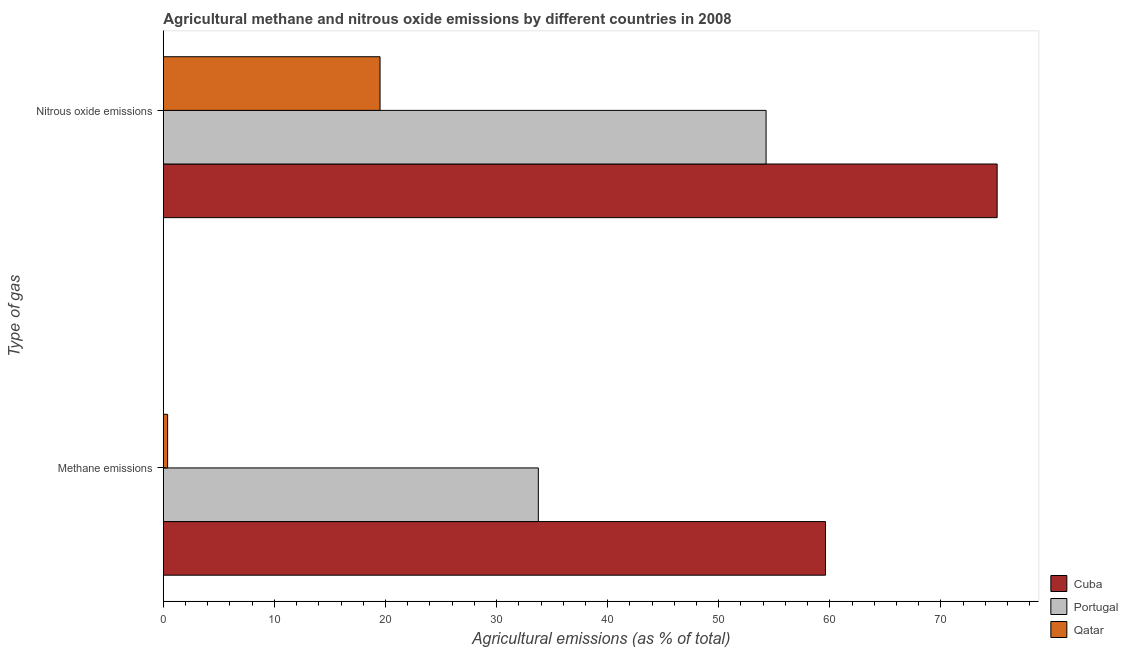How many different coloured bars are there?
Give a very brief answer. 3. How many groups of bars are there?
Offer a very short reply. 2. Are the number of bars on each tick of the Y-axis equal?
Offer a terse response. Yes. How many bars are there on the 2nd tick from the top?
Offer a very short reply. 3. What is the label of the 1st group of bars from the top?
Ensure brevity in your answer.  Nitrous oxide emissions. What is the amount of nitrous oxide emissions in Portugal?
Provide a short and direct response. 54.26. Across all countries, what is the maximum amount of nitrous oxide emissions?
Provide a short and direct response. 75.06. Across all countries, what is the minimum amount of methane emissions?
Keep it short and to the point. 0.39. In which country was the amount of methane emissions maximum?
Provide a succinct answer. Cuba. In which country was the amount of methane emissions minimum?
Your response must be concise. Qatar. What is the total amount of nitrous oxide emissions in the graph?
Provide a succinct answer. 148.83. What is the difference between the amount of methane emissions in Cuba and that in Portugal?
Make the answer very short. 25.85. What is the difference between the amount of methane emissions in Portugal and the amount of nitrous oxide emissions in Qatar?
Ensure brevity in your answer.  14.25. What is the average amount of nitrous oxide emissions per country?
Ensure brevity in your answer.  49.61. What is the difference between the amount of methane emissions and amount of nitrous oxide emissions in Portugal?
Give a very brief answer. -20.5. What is the ratio of the amount of nitrous oxide emissions in Portugal to that in Qatar?
Provide a succinct answer. 2.78. Is the amount of nitrous oxide emissions in Qatar less than that in Portugal?
Ensure brevity in your answer.  Yes. What does the 1st bar from the top in Methane emissions represents?
Keep it short and to the point. Qatar. What does the 3rd bar from the bottom in Methane emissions represents?
Offer a very short reply. Qatar. How many countries are there in the graph?
Your answer should be very brief. 3. Does the graph contain grids?
Make the answer very short. No. Where does the legend appear in the graph?
Keep it short and to the point. Bottom right. How are the legend labels stacked?
Ensure brevity in your answer.  Vertical. What is the title of the graph?
Offer a terse response. Agricultural methane and nitrous oxide emissions by different countries in 2008. Does "Canada" appear as one of the legend labels in the graph?
Make the answer very short. No. What is the label or title of the X-axis?
Keep it short and to the point. Agricultural emissions (as % of total). What is the label or title of the Y-axis?
Give a very brief answer. Type of gas. What is the Agricultural emissions (as % of total) of Cuba in Methane emissions?
Provide a succinct answer. 59.61. What is the Agricultural emissions (as % of total) in Portugal in Methane emissions?
Ensure brevity in your answer.  33.76. What is the Agricultural emissions (as % of total) in Qatar in Methane emissions?
Offer a very short reply. 0.39. What is the Agricultural emissions (as % of total) in Cuba in Nitrous oxide emissions?
Ensure brevity in your answer.  75.06. What is the Agricultural emissions (as % of total) of Portugal in Nitrous oxide emissions?
Keep it short and to the point. 54.26. What is the Agricultural emissions (as % of total) of Qatar in Nitrous oxide emissions?
Keep it short and to the point. 19.51. Across all Type of gas, what is the maximum Agricultural emissions (as % of total) in Cuba?
Make the answer very short. 75.06. Across all Type of gas, what is the maximum Agricultural emissions (as % of total) in Portugal?
Your answer should be compact. 54.26. Across all Type of gas, what is the maximum Agricultural emissions (as % of total) of Qatar?
Offer a very short reply. 19.51. Across all Type of gas, what is the minimum Agricultural emissions (as % of total) in Cuba?
Provide a succinct answer. 59.61. Across all Type of gas, what is the minimum Agricultural emissions (as % of total) of Portugal?
Make the answer very short. 33.76. Across all Type of gas, what is the minimum Agricultural emissions (as % of total) in Qatar?
Offer a very short reply. 0.39. What is the total Agricultural emissions (as % of total) of Cuba in the graph?
Keep it short and to the point. 134.67. What is the total Agricultural emissions (as % of total) in Portugal in the graph?
Give a very brief answer. 88.02. What is the total Agricultural emissions (as % of total) of Qatar in the graph?
Offer a very short reply. 19.9. What is the difference between the Agricultural emissions (as % of total) in Cuba in Methane emissions and that in Nitrous oxide emissions?
Keep it short and to the point. -15.45. What is the difference between the Agricultural emissions (as % of total) in Portugal in Methane emissions and that in Nitrous oxide emissions?
Keep it short and to the point. -20.5. What is the difference between the Agricultural emissions (as % of total) in Qatar in Methane emissions and that in Nitrous oxide emissions?
Offer a terse response. -19.12. What is the difference between the Agricultural emissions (as % of total) in Cuba in Methane emissions and the Agricultural emissions (as % of total) in Portugal in Nitrous oxide emissions?
Make the answer very short. 5.35. What is the difference between the Agricultural emissions (as % of total) in Cuba in Methane emissions and the Agricultural emissions (as % of total) in Qatar in Nitrous oxide emissions?
Provide a succinct answer. 40.1. What is the difference between the Agricultural emissions (as % of total) of Portugal in Methane emissions and the Agricultural emissions (as % of total) of Qatar in Nitrous oxide emissions?
Offer a very short reply. 14.25. What is the average Agricultural emissions (as % of total) of Cuba per Type of gas?
Offer a terse response. 67.33. What is the average Agricultural emissions (as % of total) in Portugal per Type of gas?
Your response must be concise. 44.01. What is the average Agricultural emissions (as % of total) in Qatar per Type of gas?
Provide a succinct answer. 9.95. What is the difference between the Agricultural emissions (as % of total) in Cuba and Agricultural emissions (as % of total) in Portugal in Methane emissions?
Keep it short and to the point. 25.85. What is the difference between the Agricultural emissions (as % of total) of Cuba and Agricultural emissions (as % of total) of Qatar in Methane emissions?
Provide a succinct answer. 59.22. What is the difference between the Agricultural emissions (as % of total) in Portugal and Agricultural emissions (as % of total) in Qatar in Methane emissions?
Your answer should be compact. 33.37. What is the difference between the Agricultural emissions (as % of total) of Cuba and Agricultural emissions (as % of total) of Portugal in Nitrous oxide emissions?
Give a very brief answer. 20.8. What is the difference between the Agricultural emissions (as % of total) in Cuba and Agricultural emissions (as % of total) in Qatar in Nitrous oxide emissions?
Keep it short and to the point. 55.55. What is the difference between the Agricultural emissions (as % of total) in Portugal and Agricultural emissions (as % of total) in Qatar in Nitrous oxide emissions?
Give a very brief answer. 34.75. What is the ratio of the Agricultural emissions (as % of total) of Cuba in Methane emissions to that in Nitrous oxide emissions?
Keep it short and to the point. 0.79. What is the ratio of the Agricultural emissions (as % of total) of Portugal in Methane emissions to that in Nitrous oxide emissions?
Your answer should be very brief. 0.62. What is the ratio of the Agricultural emissions (as % of total) of Qatar in Methane emissions to that in Nitrous oxide emissions?
Your response must be concise. 0.02. What is the difference between the highest and the second highest Agricultural emissions (as % of total) in Cuba?
Ensure brevity in your answer.  15.45. What is the difference between the highest and the second highest Agricultural emissions (as % of total) in Portugal?
Provide a succinct answer. 20.5. What is the difference between the highest and the second highest Agricultural emissions (as % of total) of Qatar?
Offer a terse response. 19.12. What is the difference between the highest and the lowest Agricultural emissions (as % of total) in Cuba?
Provide a succinct answer. 15.45. What is the difference between the highest and the lowest Agricultural emissions (as % of total) of Portugal?
Ensure brevity in your answer.  20.5. What is the difference between the highest and the lowest Agricultural emissions (as % of total) in Qatar?
Your answer should be very brief. 19.12. 